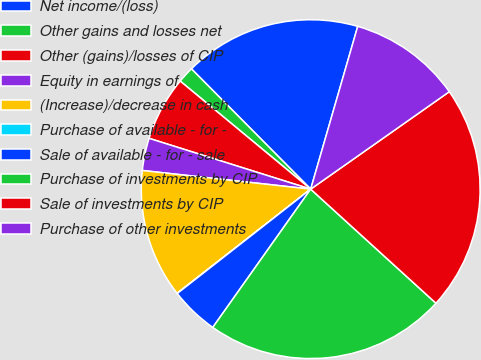Convert chart. <chart><loc_0><loc_0><loc_500><loc_500><pie_chart><fcel>Net income/(loss)<fcel>Other gains and losses net<fcel>Other (gains)/losses of CIP<fcel>Equity in earnings of<fcel>(Increase)/decrease in cash<fcel>Purchase of available - for -<fcel>Sale of available - for - sale<fcel>Purchase of investments by CIP<fcel>Sale of investments by CIP<fcel>Purchase of other investments<nl><fcel>16.91%<fcel>1.56%<fcel>6.16%<fcel>3.09%<fcel>12.3%<fcel>0.02%<fcel>4.63%<fcel>23.05%<fcel>21.51%<fcel>10.77%<nl></chart> 